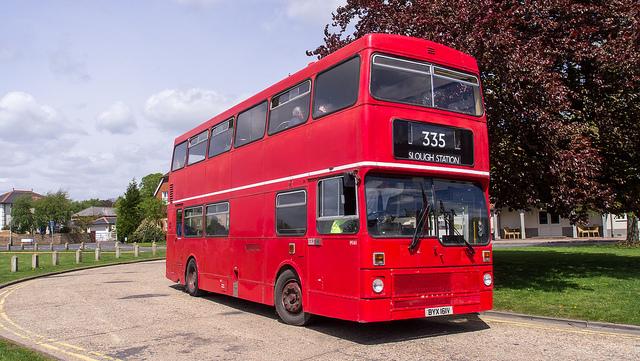What number is on the bus?
Concise answer only. 335. What kind of tour bus is this?
Be succinct. Double decker. How many cars are in front of the trolley?
Be succinct. 0. How many decks is the bus?
Give a very brief answer. 2. What color is the bus?
Keep it brief. Red. 